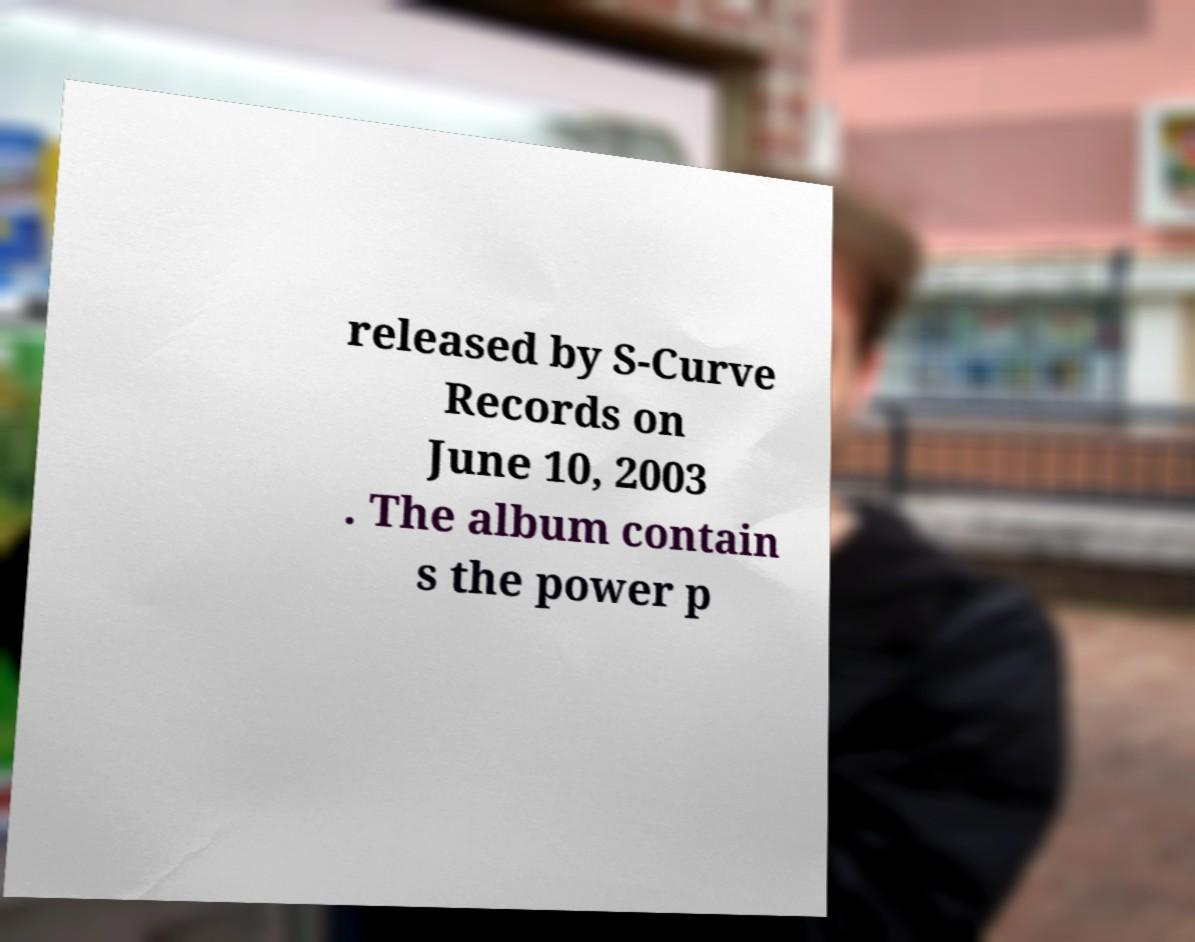What is the significance of the date June 10, 2003, in the context of music albums? June 10, 2003, marks the release date of an album by S-Curve Records. Release dates are often celebrated anniversaries in the music world, marking moments when new music was shared globally, potentially influencing other music trends and industry events. 